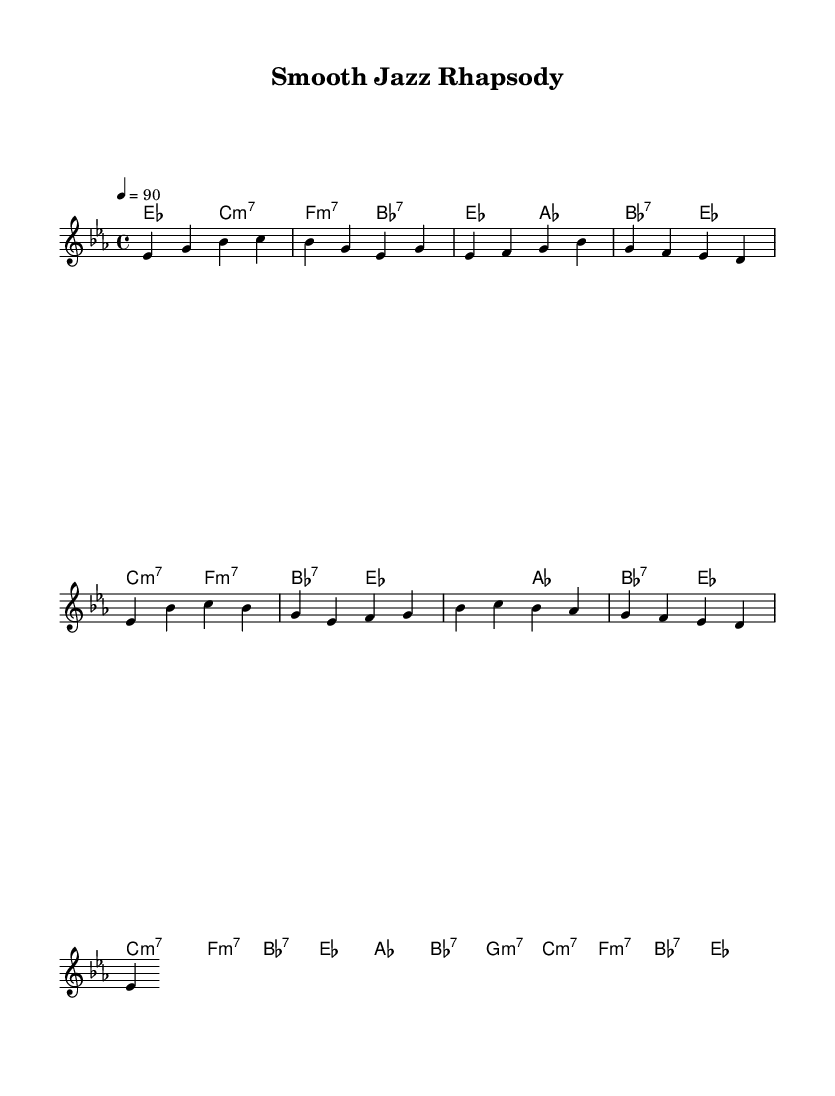What is the key signature of this music? The key signature of the music is E-flat major, which has three flats: B-flat, E-flat, and A-flat. It can be identified by looking for flat symbols at the beginning of the staff.
Answer: E-flat major What is the time signature of this music? The time signature is found in the beginning of the score; it appears as a fraction. Here, it is written as 4/4, which indicates four beats per measure and a quarter note gets one beat.
Answer: 4/4 What is the tempo marking provided? The tempo marking is indicated at the beginning of the piece, showing the speed of the piece. It states "4 = 90", meaning that a quarter note should be played at a speed of 90 beats per minute.
Answer: 90 What is the first chord in the piece? The first chord is indicated in the chord names section and is the first chord progression listed. Here, it is E-flat major. This can be identified at the start of the score before the melody begins.
Answer: E-flat major How many measures are in the introduction? To find the number of measures in the introduction, count the bar lines that separate the different sections. There are four measures indicated in the introduction of the score.
Answer: 4 What genre influences this piece? The genre influence can be inferred from the title and overall style of the music, which incorporates elements typically associated with jazz-influenced Hip Hop, notable for its smooth melodies and vocal style.
Answer: Jazz-influenced Hip Hop Which vocal style is reminiscent of Nat King Cole in this piece? The smooth vocal style characterized by warm and rich tones can be derived from the melodic structure and artistic intention of the piece, closely aligning with Nat King Cole's signature sound.
Answer: Smooth vocals 